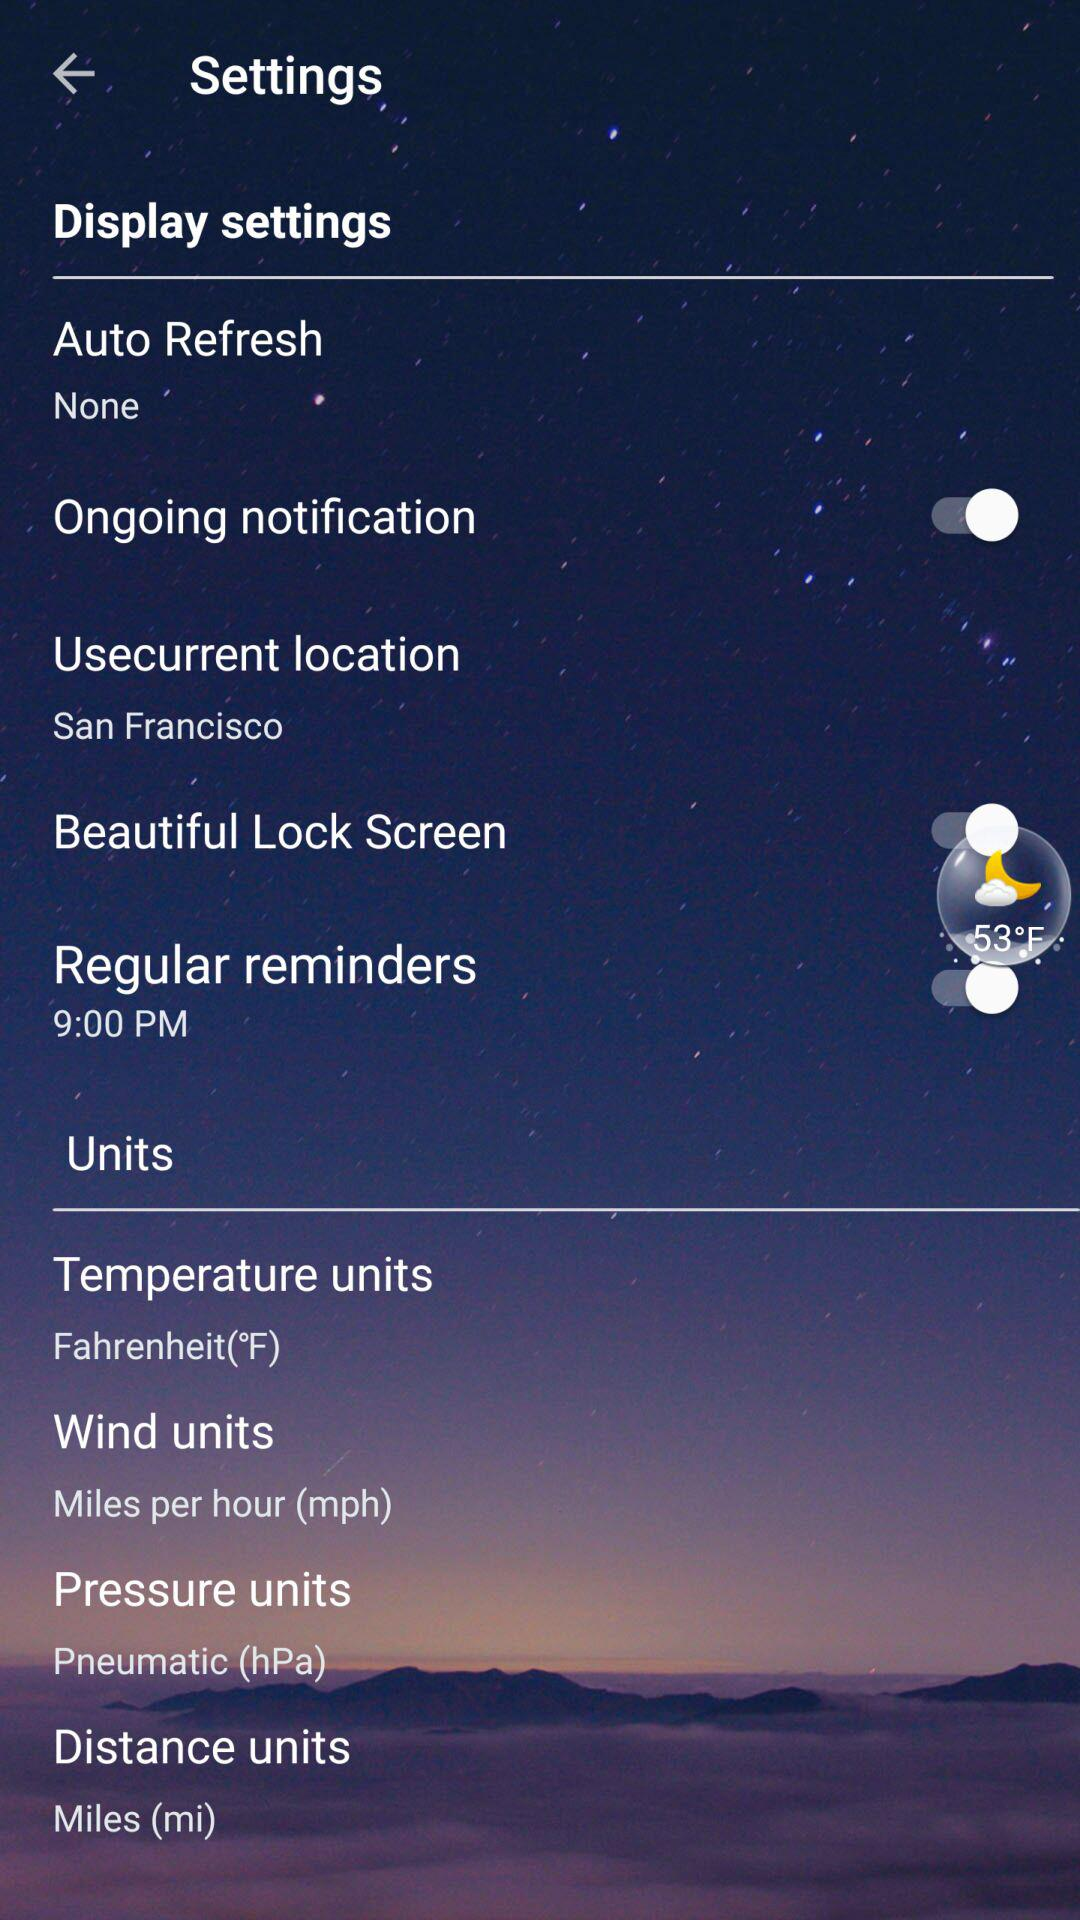What is the time of regular reminders? The time of regular reminders is 9:00 PM. 